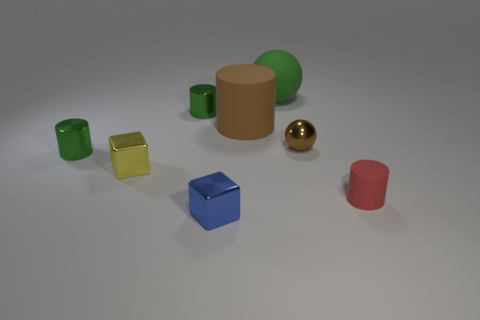There is a cylinder that is both to the right of the small blue cube and to the left of the red matte thing; what is its size?
Provide a succinct answer. Large. There is a object that is both behind the brown shiny thing and to the left of the brown cylinder; what shape is it?
Your response must be concise. Cylinder. Are there any yellow spheres?
Your answer should be very brief. No. What material is the other tiny object that is the same shape as the yellow shiny object?
Your answer should be compact. Metal. There is a big object behind the metal cylinder behind the green metal cylinder in front of the large matte cylinder; what shape is it?
Your response must be concise. Sphere. There is a cylinder that is the same color as the metallic ball; what material is it?
Offer a terse response. Rubber. How many other matte things have the same shape as the red object?
Your response must be concise. 1. There is a rubber object that is on the left side of the big green matte object; does it have the same color as the small block behind the tiny red cylinder?
Your answer should be very brief. No. There is a sphere that is the same size as the blue shiny block; what material is it?
Your answer should be very brief. Metal. Are there any brown matte things of the same size as the red matte thing?
Your answer should be compact. No. 